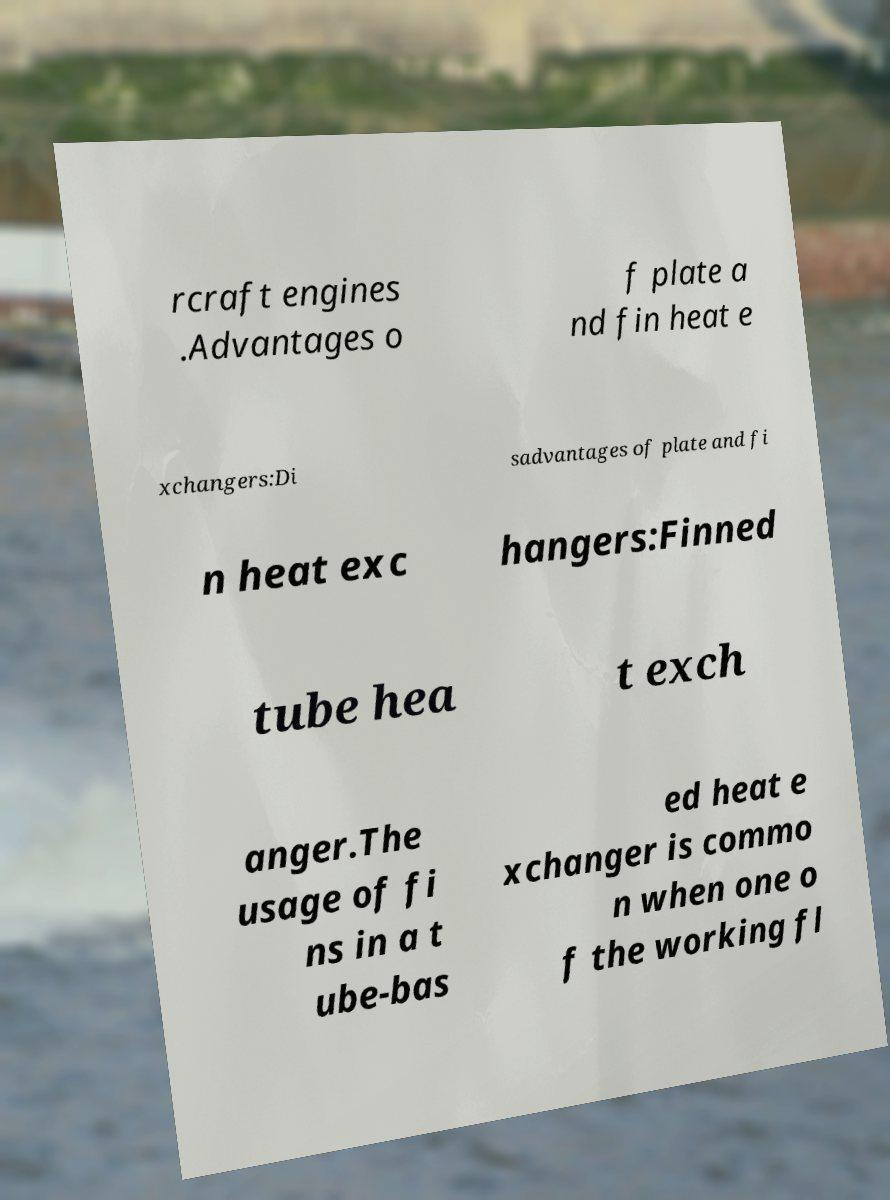I need the written content from this picture converted into text. Can you do that? rcraft engines .Advantages o f plate a nd fin heat e xchangers:Di sadvantages of plate and fi n heat exc hangers:Finned tube hea t exch anger.The usage of fi ns in a t ube-bas ed heat e xchanger is commo n when one o f the working fl 